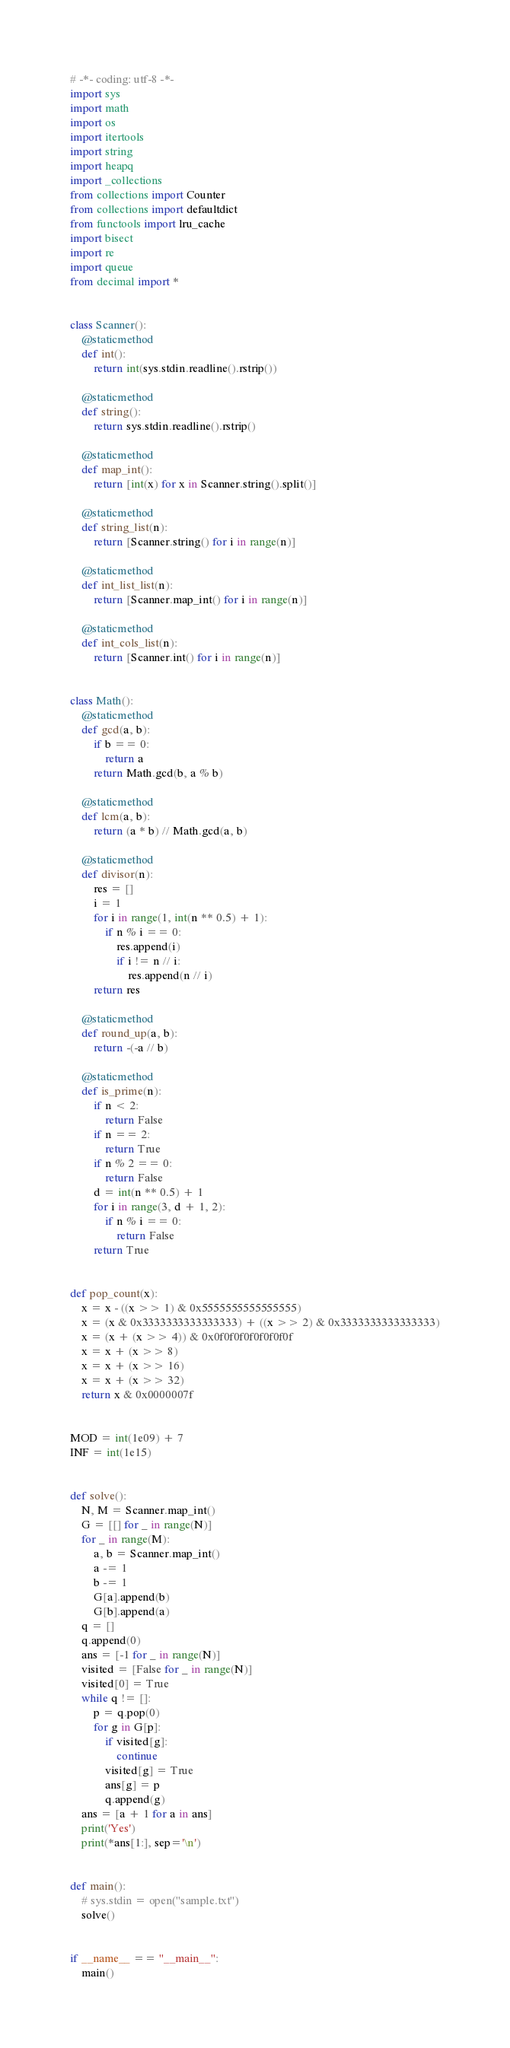<code> <loc_0><loc_0><loc_500><loc_500><_Python_># -*- coding: utf-8 -*-
import sys
import math
import os
import itertools
import string
import heapq
import _collections
from collections import Counter
from collections import defaultdict
from functools import lru_cache
import bisect
import re
import queue
from decimal import *


class Scanner():
    @staticmethod
    def int():
        return int(sys.stdin.readline().rstrip())

    @staticmethod
    def string():
        return sys.stdin.readline().rstrip()

    @staticmethod
    def map_int():
        return [int(x) for x in Scanner.string().split()]

    @staticmethod
    def string_list(n):
        return [Scanner.string() for i in range(n)]

    @staticmethod
    def int_list_list(n):
        return [Scanner.map_int() for i in range(n)]

    @staticmethod
    def int_cols_list(n):
        return [Scanner.int() for i in range(n)]


class Math():
    @staticmethod
    def gcd(a, b):
        if b == 0:
            return a
        return Math.gcd(b, a % b)

    @staticmethod
    def lcm(a, b):
        return (a * b) // Math.gcd(a, b)

    @staticmethod
    def divisor(n):
        res = []
        i = 1
        for i in range(1, int(n ** 0.5) + 1):
            if n % i == 0:
                res.append(i)
                if i != n // i:
                    res.append(n // i)
        return res

    @staticmethod
    def round_up(a, b):
        return -(-a // b)

    @staticmethod
    def is_prime(n):
        if n < 2:
            return False
        if n == 2:
            return True
        if n % 2 == 0:
            return False
        d = int(n ** 0.5) + 1
        for i in range(3, d + 1, 2):
            if n % i == 0:
                return False
        return True


def pop_count(x):
    x = x - ((x >> 1) & 0x5555555555555555)
    x = (x & 0x3333333333333333) + ((x >> 2) & 0x3333333333333333)
    x = (x + (x >> 4)) & 0x0f0f0f0f0f0f0f0f
    x = x + (x >> 8)
    x = x + (x >> 16)
    x = x + (x >> 32)
    return x & 0x0000007f


MOD = int(1e09) + 7
INF = int(1e15)


def solve():
    N, M = Scanner.map_int()
    G = [[] for _ in range(N)]
    for _ in range(M):
        a, b = Scanner.map_int()
        a -= 1
        b -= 1
        G[a].append(b)
        G[b].append(a)
    q = []
    q.append(0)
    ans = [-1 for _ in range(N)]
    visited = [False for _ in range(N)]
    visited[0] = True
    while q != []:
        p = q.pop(0)
        for g in G[p]:
            if visited[g]:
                continue
            visited[g] = True
            ans[g] = p
            q.append(g)
    ans = [a + 1 for a in ans]
    print('Yes')
    print(*ans[1:], sep='\n')


def main():
    # sys.stdin = open("sample.txt")
    solve()


if __name__ == "__main__":
    main()
</code> 